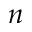Convert formula to latex. <formula><loc_0><loc_0><loc_500><loc_500>n</formula> 